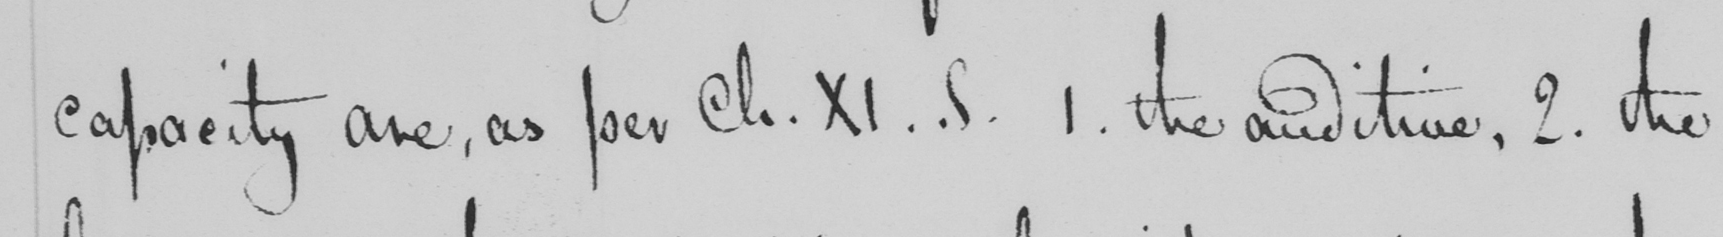What does this handwritten line say? capacity are , as per Ch . XI . S . 1 . the auditive , 2 . the 